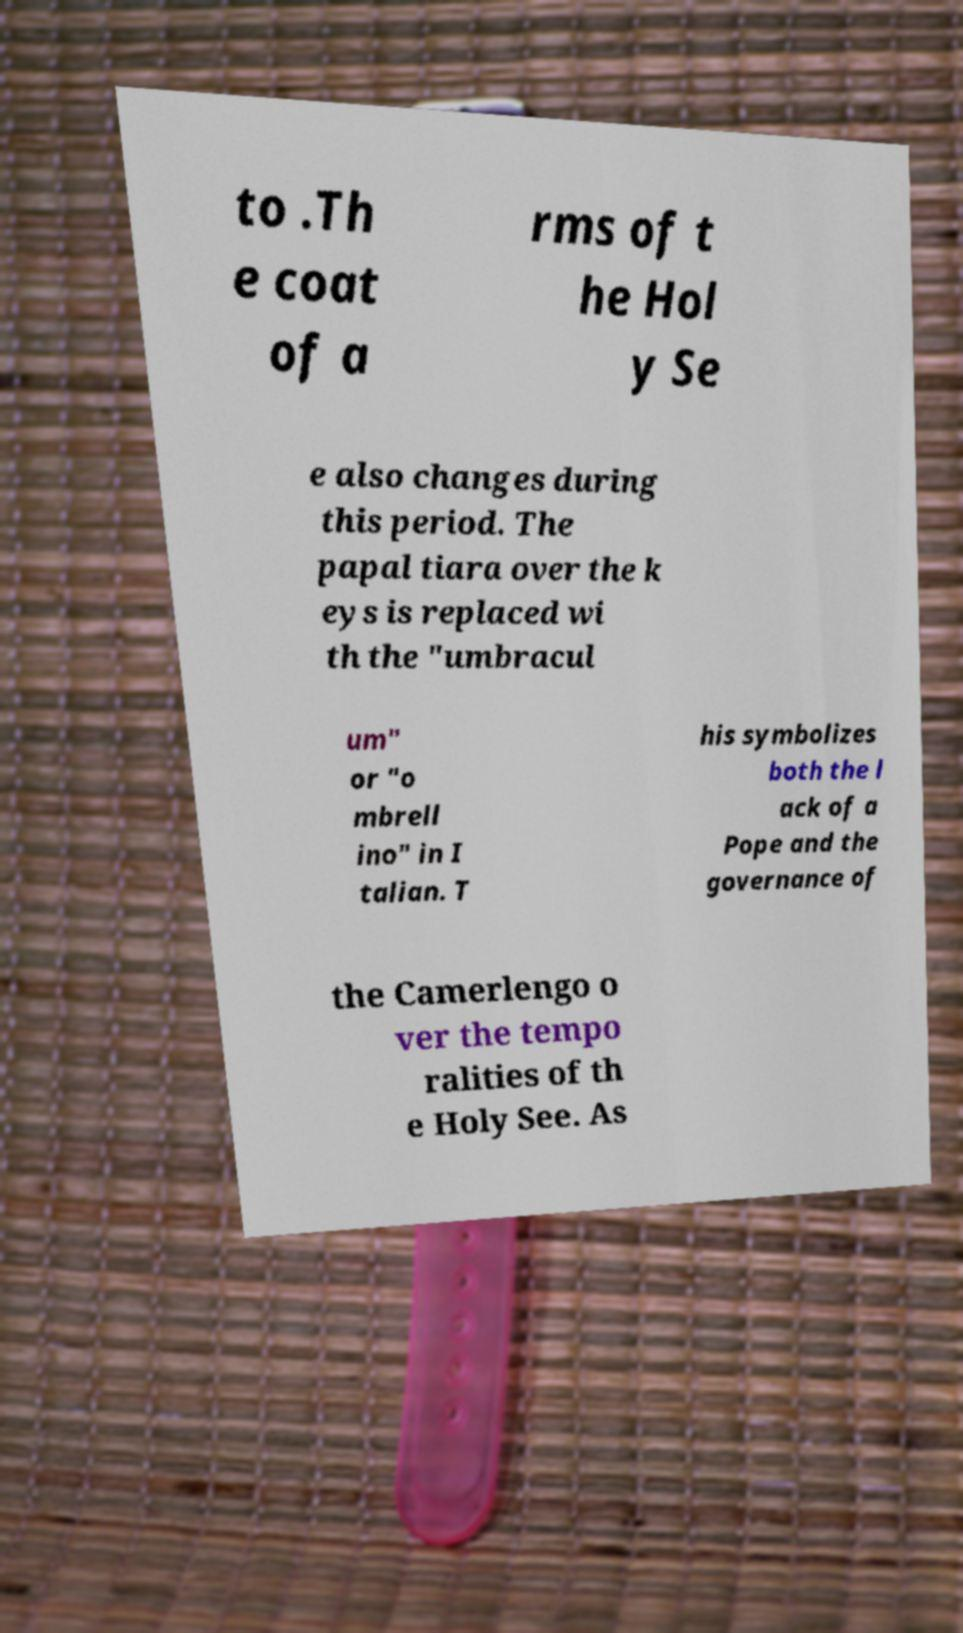Could you extract and type out the text from this image? to .Th e coat of a rms of t he Hol y Se e also changes during this period. The papal tiara over the k eys is replaced wi th the "umbracul um" or "o mbrell ino" in I talian. T his symbolizes both the l ack of a Pope and the governance of the Camerlengo o ver the tempo ralities of th e Holy See. As 